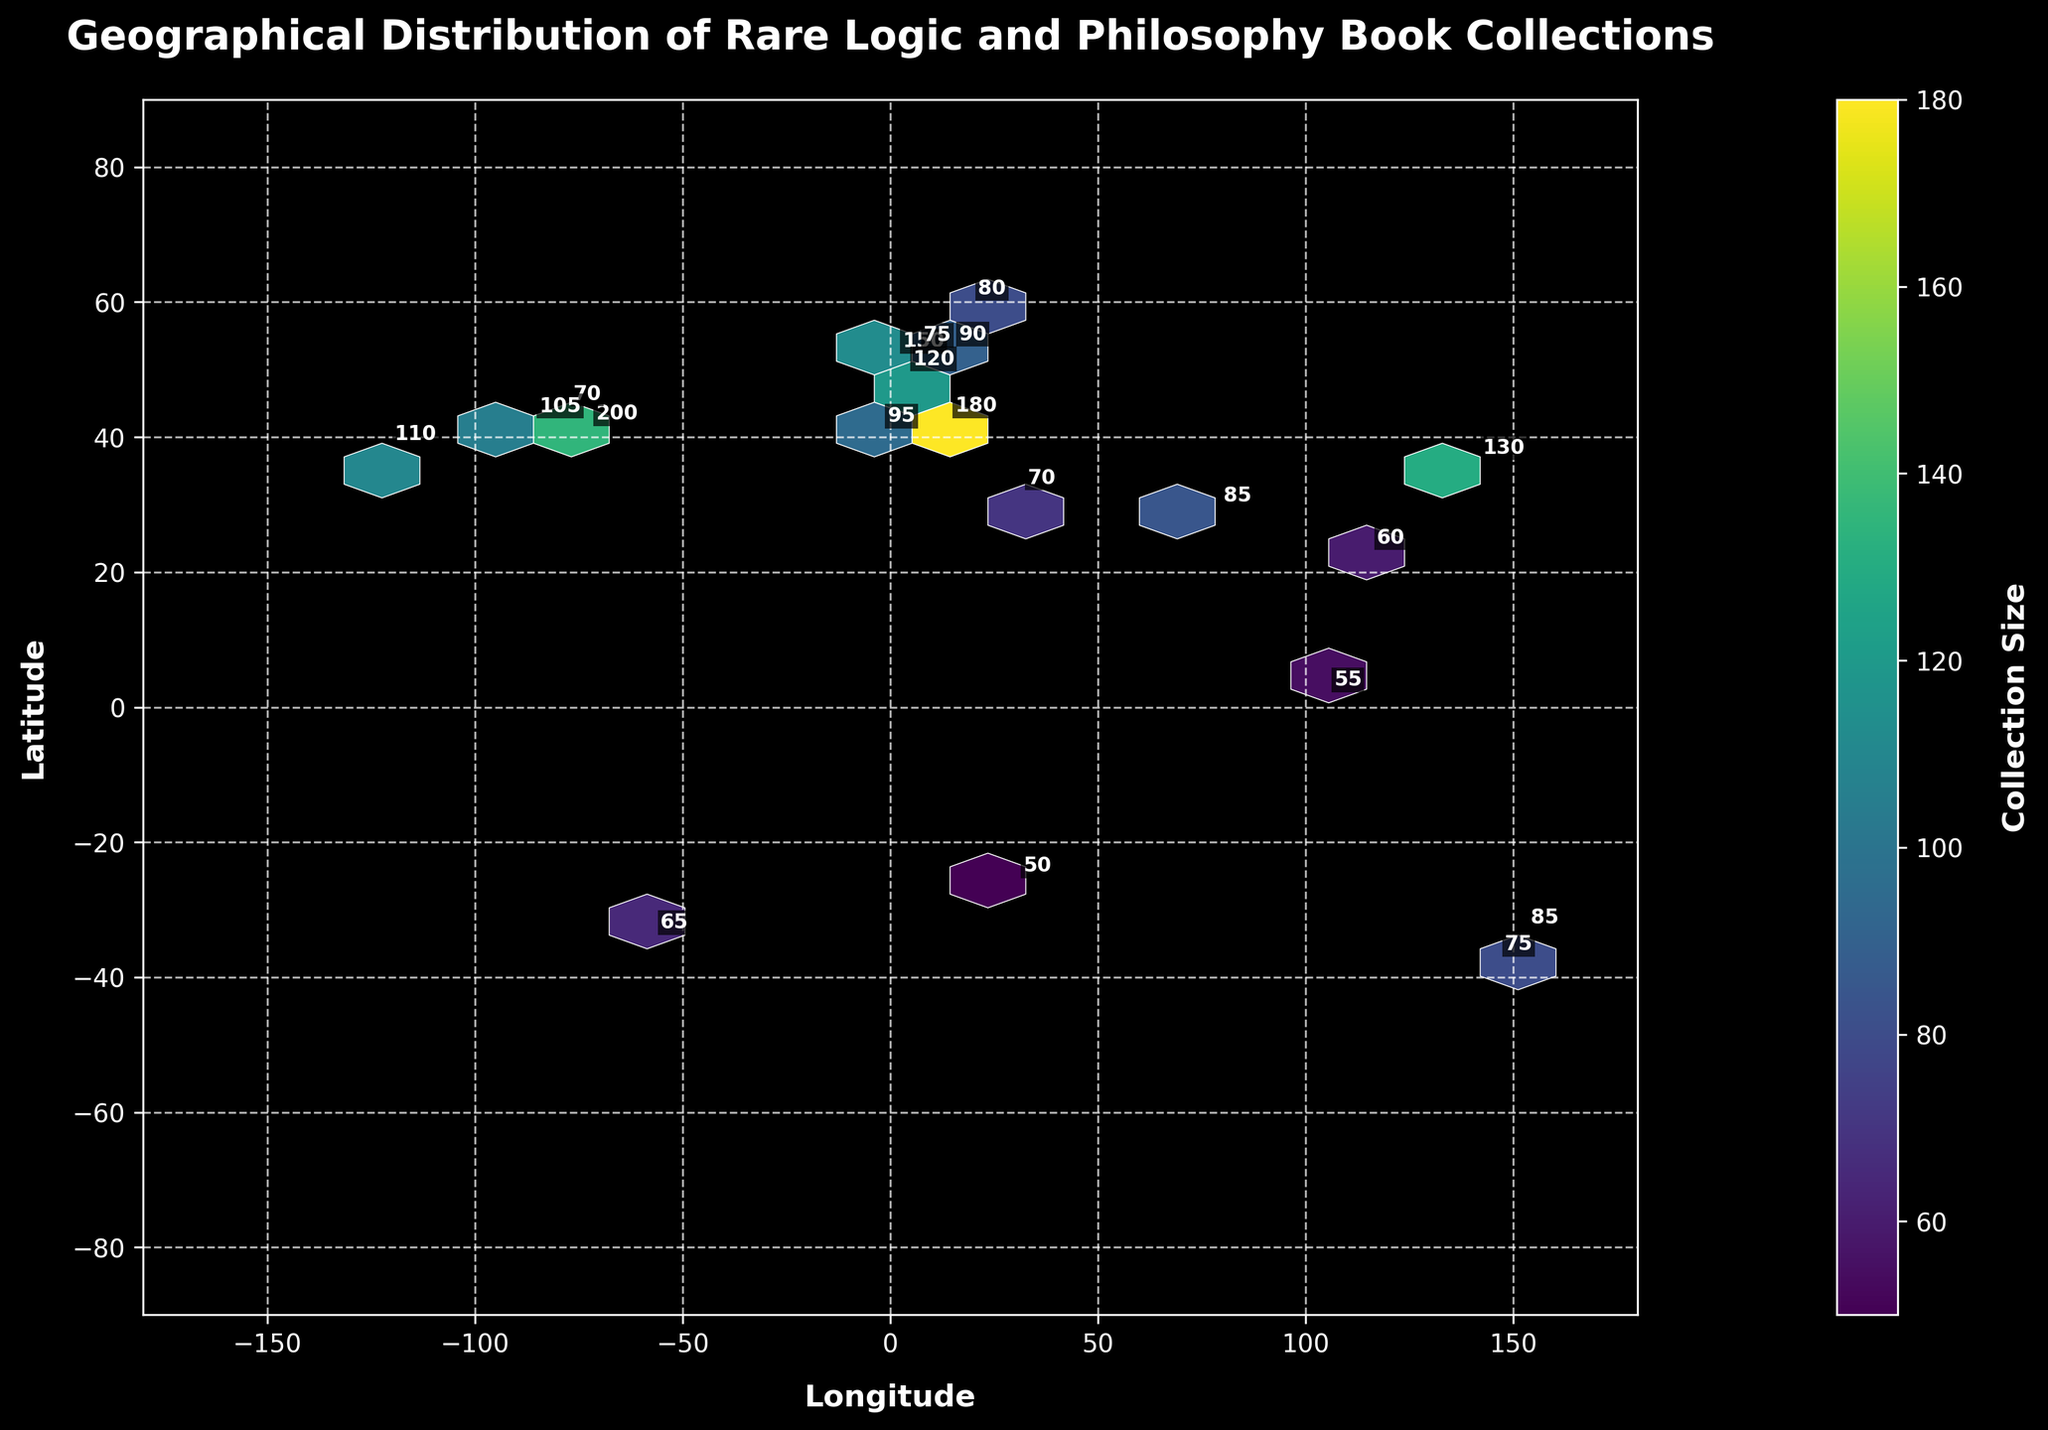How many data points are shown on the map? By visually counting the number of data points or annotations on the map, one can determine the total.
Answer: 20 What is the title of the plot? The title is usually displayed at the top of the plot.
Answer: Geographical Distribution of Rare Logic and Philosophy Book Collections Which city has the largest collection size, and what is that size? The city with the largest collection size is the one with the highest number next to its annotation. Specifically, identify the city and read its respective collection size.
Answer: New York City, 200 How are the collection sizes represented visually on the plot? Hexbin plots represent the size of collections using a color gradient. The color bar legend indicates that darker colors correspond to larger collection sizes.
Answer: By color intensity (darker for larger sizes) What is the approximate latitude and longitude range covered in the plot? The axes of the plot represent latitude and longitude. Checking the minimum and maximum values on these axes will give the range.
Answer: Longitude: -180 to 180, Latitude: -90 to 90 Compare the collection sizes of Toronto and Buenos Aires. Which one is larger? Locate these two cities on the map and compare the numbers next to them.
Answer: Toronto, 70 (Buenos Aires, 65) Which continent seems to have the most clustered book collections according to the plot? By observing the density of points in particular regions on the map, we can determine which continent has the most clusters.
Answer: Europe What is the total collection size for the cities in Europe? Identify the European cities and sum up their collection sizes: London (150) + Paris (120) + Berlin (90) + Rome (180) + Amsterdam (75) + Madrid (95) + Stockholm (80).
Answer: 790 How does the collection size in Cairo compare to that in Johannesburg? Locate Cairo and Johannesburg and compare their annotated collection sizes.
Answer: Cairo, 70 (Johannesburg, 50) 